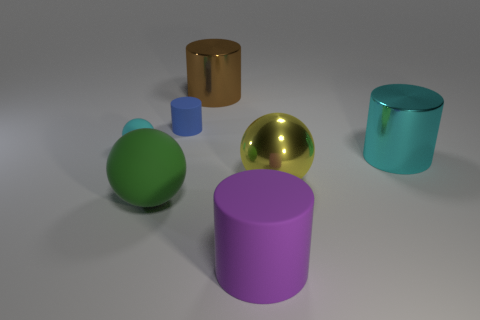Is there a tiny object that has the same material as the cyan ball?
Offer a terse response. Yes. Is the material of the large cyan object the same as the small blue cylinder?
Your answer should be very brief. No. There is a large metal object behind the cyan matte object; how many small rubber cylinders are on the right side of it?
Keep it short and to the point. 0. What number of purple objects are cylinders or big metallic cylinders?
Offer a very short reply. 1. There is a metal thing that is behind the cyan object right of the matte sphere in front of the large cyan cylinder; what shape is it?
Your response must be concise. Cylinder. What color is the other rubber object that is the same size as the purple matte thing?
Offer a very short reply. Green. How many large yellow things have the same shape as the purple rubber object?
Your answer should be compact. 0. There is a green matte object; is its size the same as the ball that is to the right of the brown metal cylinder?
Your response must be concise. Yes. The large rubber thing that is left of the large shiny cylinder that is on the left side of the cyan cylinder is what shape?
Offer a terse response. Sphere. Is the number of tiny blue objects in front of the blue matte thing less than the number of small objects?
Provide a short and direct response. Yes. 